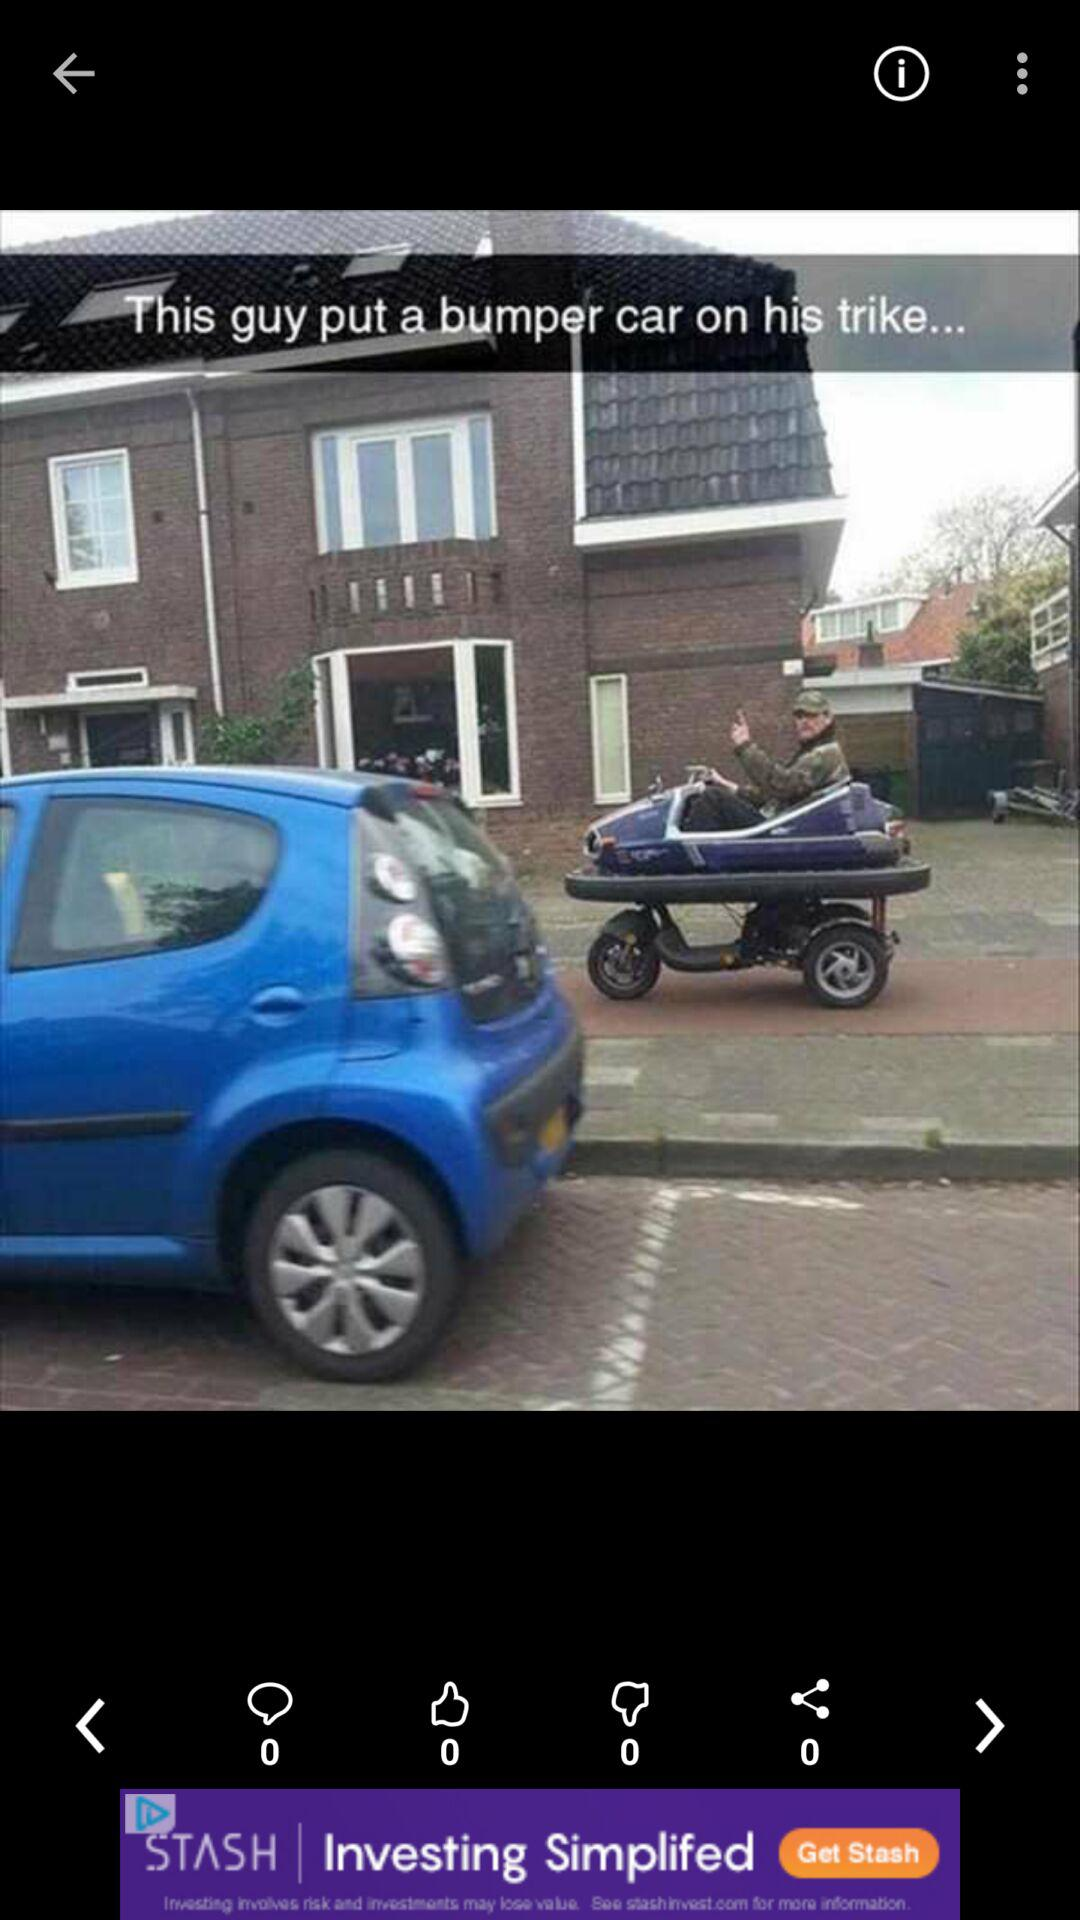What is the number of shares? The number of shares is 0. 